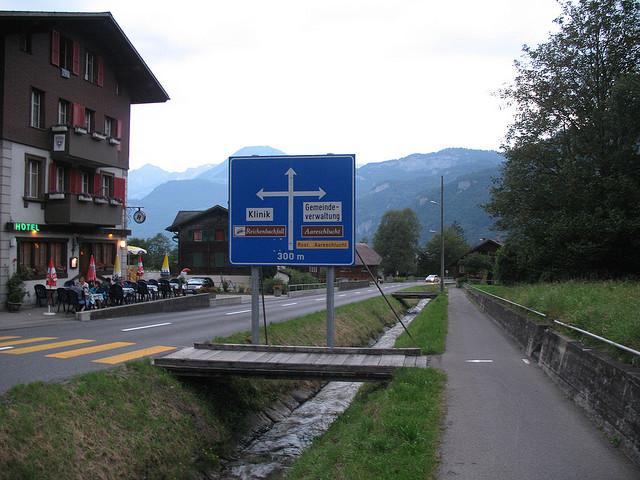What color is the grass?
Keep it brief. Green. Is it night time?
Answer briefly. No. Is this an Austrian street sign?
Short answer required. Yes. 